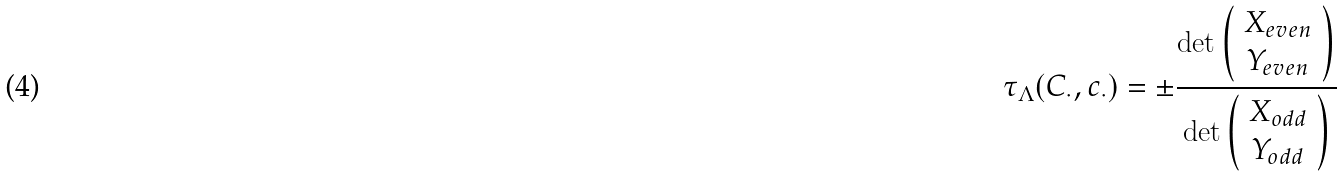<formula> <loc_0><loc_0><loc_500><loc_500>\tau _ { \Lambda } ( C _ { \cdot } , { c } _ { \cdot } ) = \pm \frac { \det \left ( \begin{array} { c } X _ { e v e n } \\ Y _ { e v e n } \end{array} \right ) } { \det \left ( \begin{array} { c } X _ { o d d } \\ Y _ { o d d } \end{array} \right ) }</formula> 